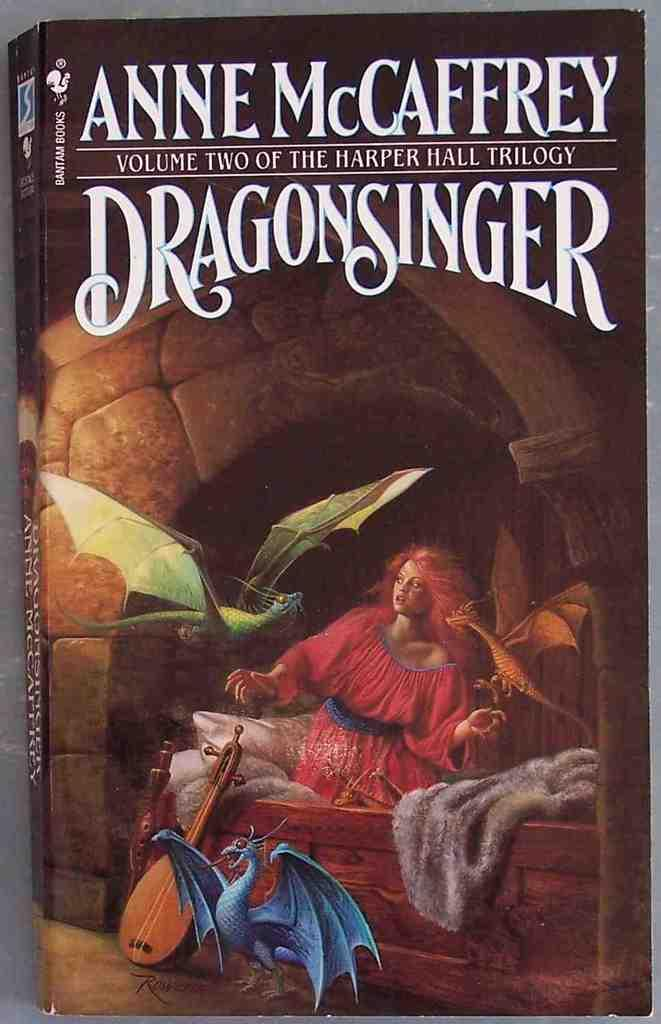<image>
Write a terse but informative summary of the picture. The book is volume two of a three book series. 